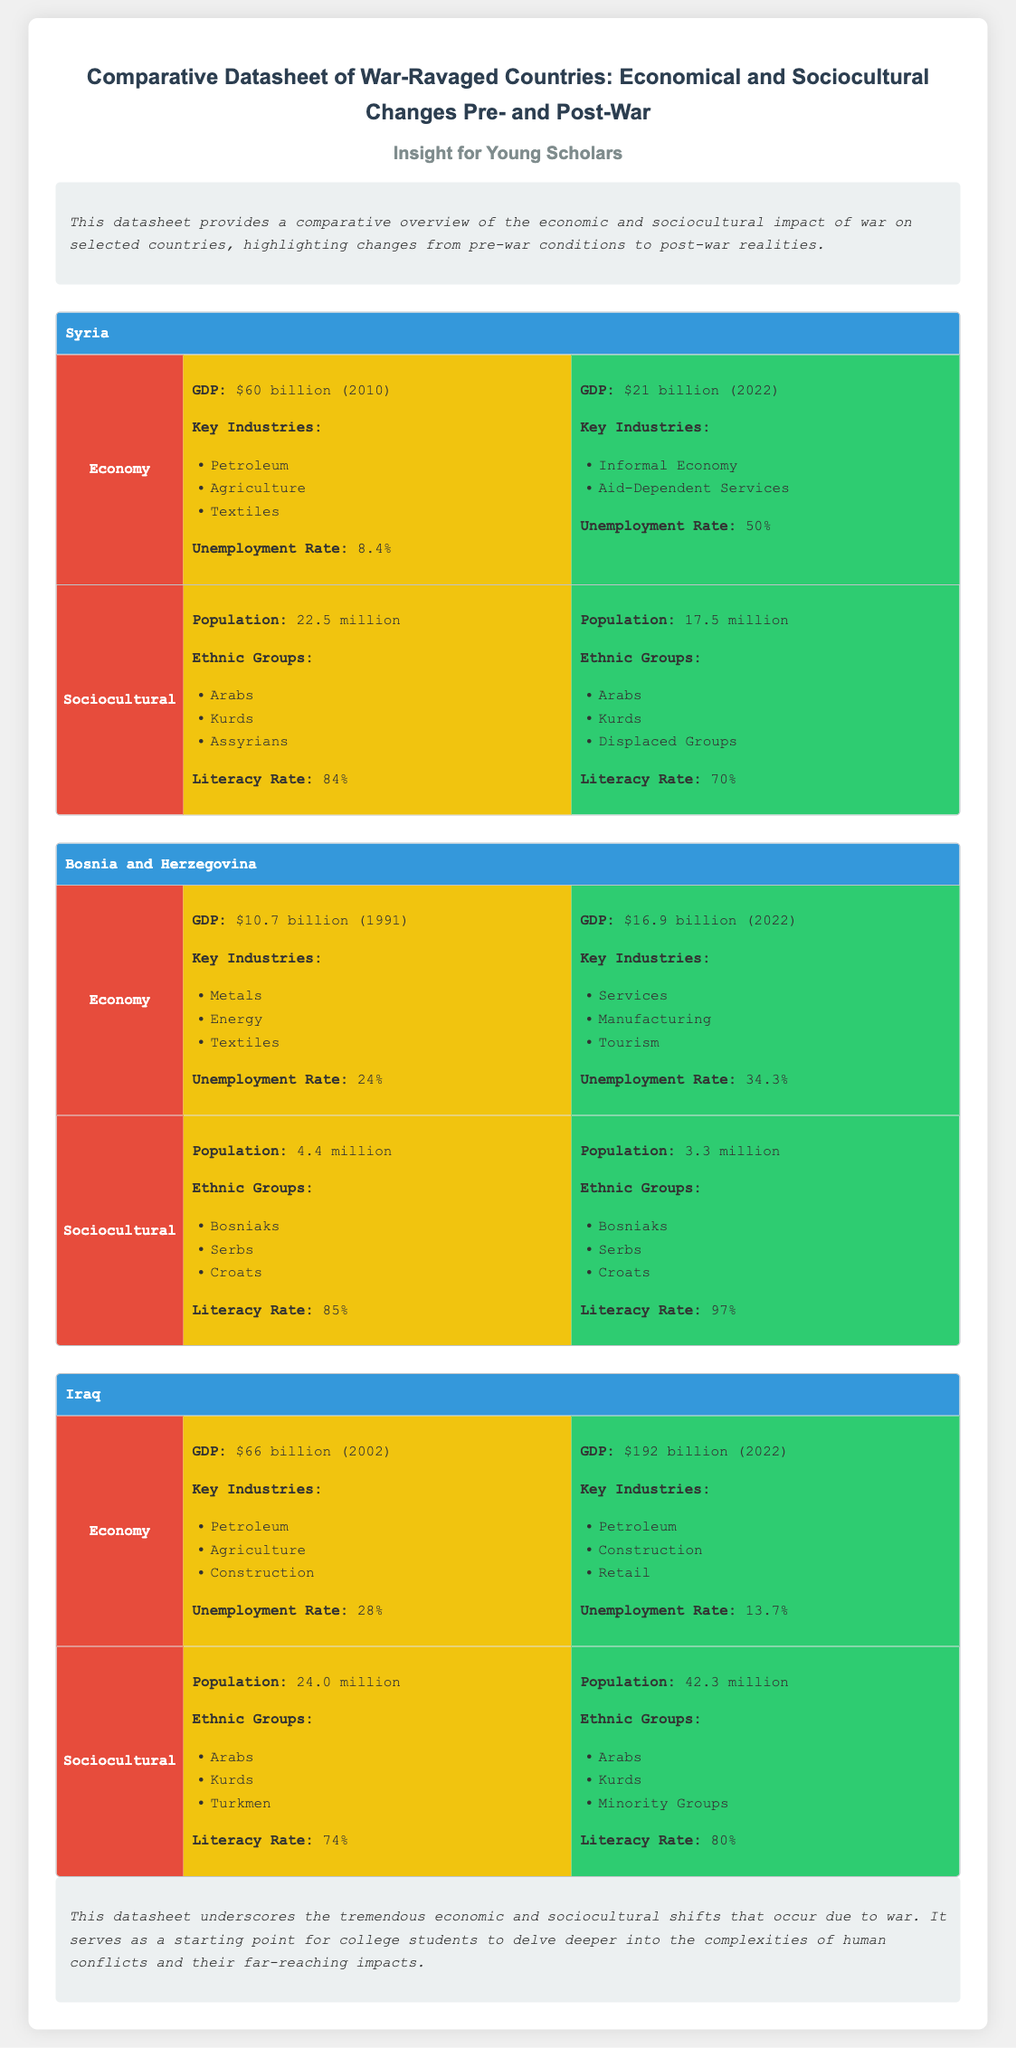What was Syria's GDP in 2010? The GDP of Syria in 2010 was stated as $60 billion.
Answer: $60 billion What are the key industries of Bosnia and Herzegovina post-war? The key industries of Bosnia and Herzegovina post-war include Services, Manufacturing, and Tourism.
Answer: Services, Manufacturing, Tourism What was the unemployment rate in Iraq before the war? The unemployment rate in Iraq before the war was 28%.
Answer: 28% What is the population of Syria post-war? The population of Syria post-war is mentioned as 17.5 million.
Answer: 17.5 million Which ethnic groups were present in Iraq pre-war? The ethnic groups present in Iraq pre-war include Arabs, Kurds, and Turkmen.
Answer: Arabs, Kurds, Turkmen Name one sociocultural change in Syria due to war. The literacy rate in Syria post-war dropped from 84% pre-war to 70% post-war.
Answer: Literacy rate What was Bosnia and Herzegovina's GDP in 1991? The GDP of Bosnia and Herzegovina in 1991 was stated as $10.7 billion.
Answer: $10.7 billion What trend is observed in Iraq's GDP from pre-war to post-war? Iraq's GDP increased from $66 billion pre-war to $192 billion post-war.
Answer: Increased Which country had the highest literacy rate post-war? Bosnia and Herzegovina had the highest literacy rate post-war at 97%.
Answer: 97% 